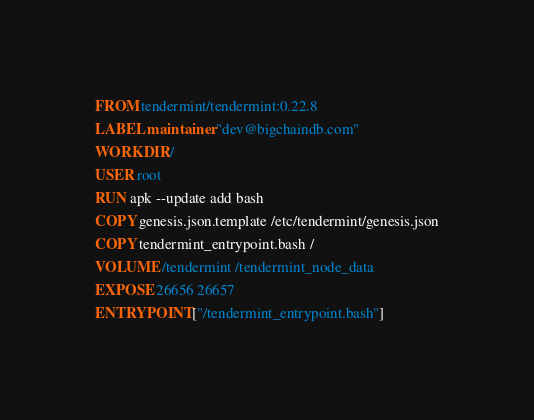<code> <loc_0><loc_0><loc_500><loc_500><_Dockerfile_>FROM tendermint/tendermint:0.22.8
LABEL maintainer "dev@bigchaindb.com"
WORKDIR /
USER root
RUN apk --update add bash
COPY genesis.json.template /etc/tendermint/genesis.json
COPY tendermint_entrypoint.bash /
VOLUME /tendermint /tendermint_node_data
EXPOSE 26656 26657
ENTRYPOINT ["/tendermint_entrypoint.bash"]
</code> 